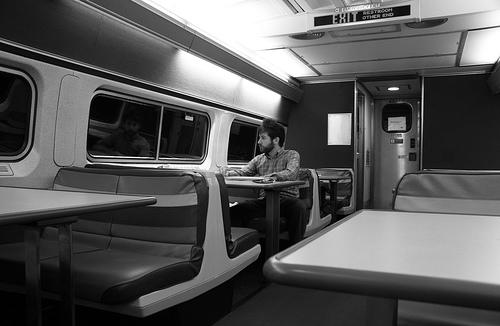How many seats are there?
Give a very brief answer. 6. Who would be able to sit here?
Quick response, please. Passenger. Is the train crowded?
Short answer required. No. Is this a color or black and white photo?
Short answer required. Black and white. Where is the man sitting?
Quick response, please. Train. 